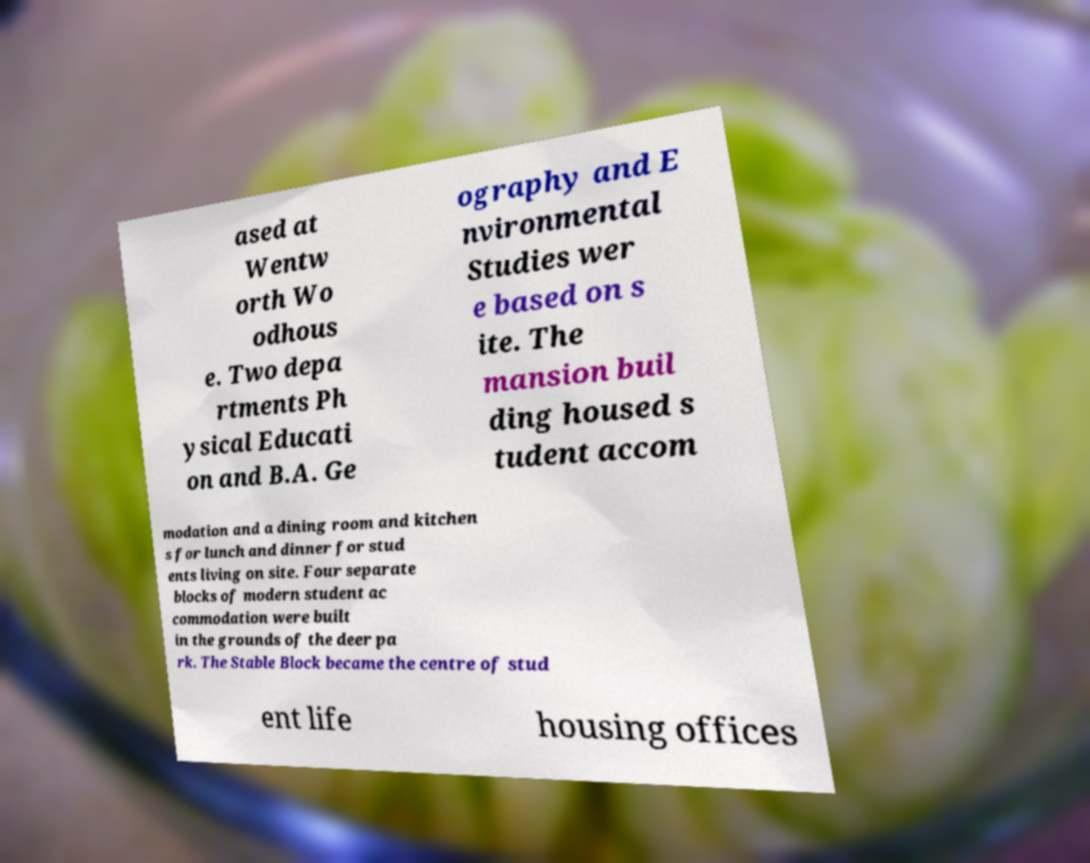What messages or text are displayed in this image? I need them in a readable, typed format. ased at Wentw orth Wo odhous e. Two depa rtments Ph ysical Educati on and B.A. Ge ography and E nvironmental Studies wer e based on s ite. The mansion buil ding housed s tudent accom modation and a dining room and kitchen s for lunch and dinner for stud ents living on site. Four separate blocks of modern student ac commodation were built in the grounds of the deer pa rk. The Stable Block became the centre of stud ent life housing offices 